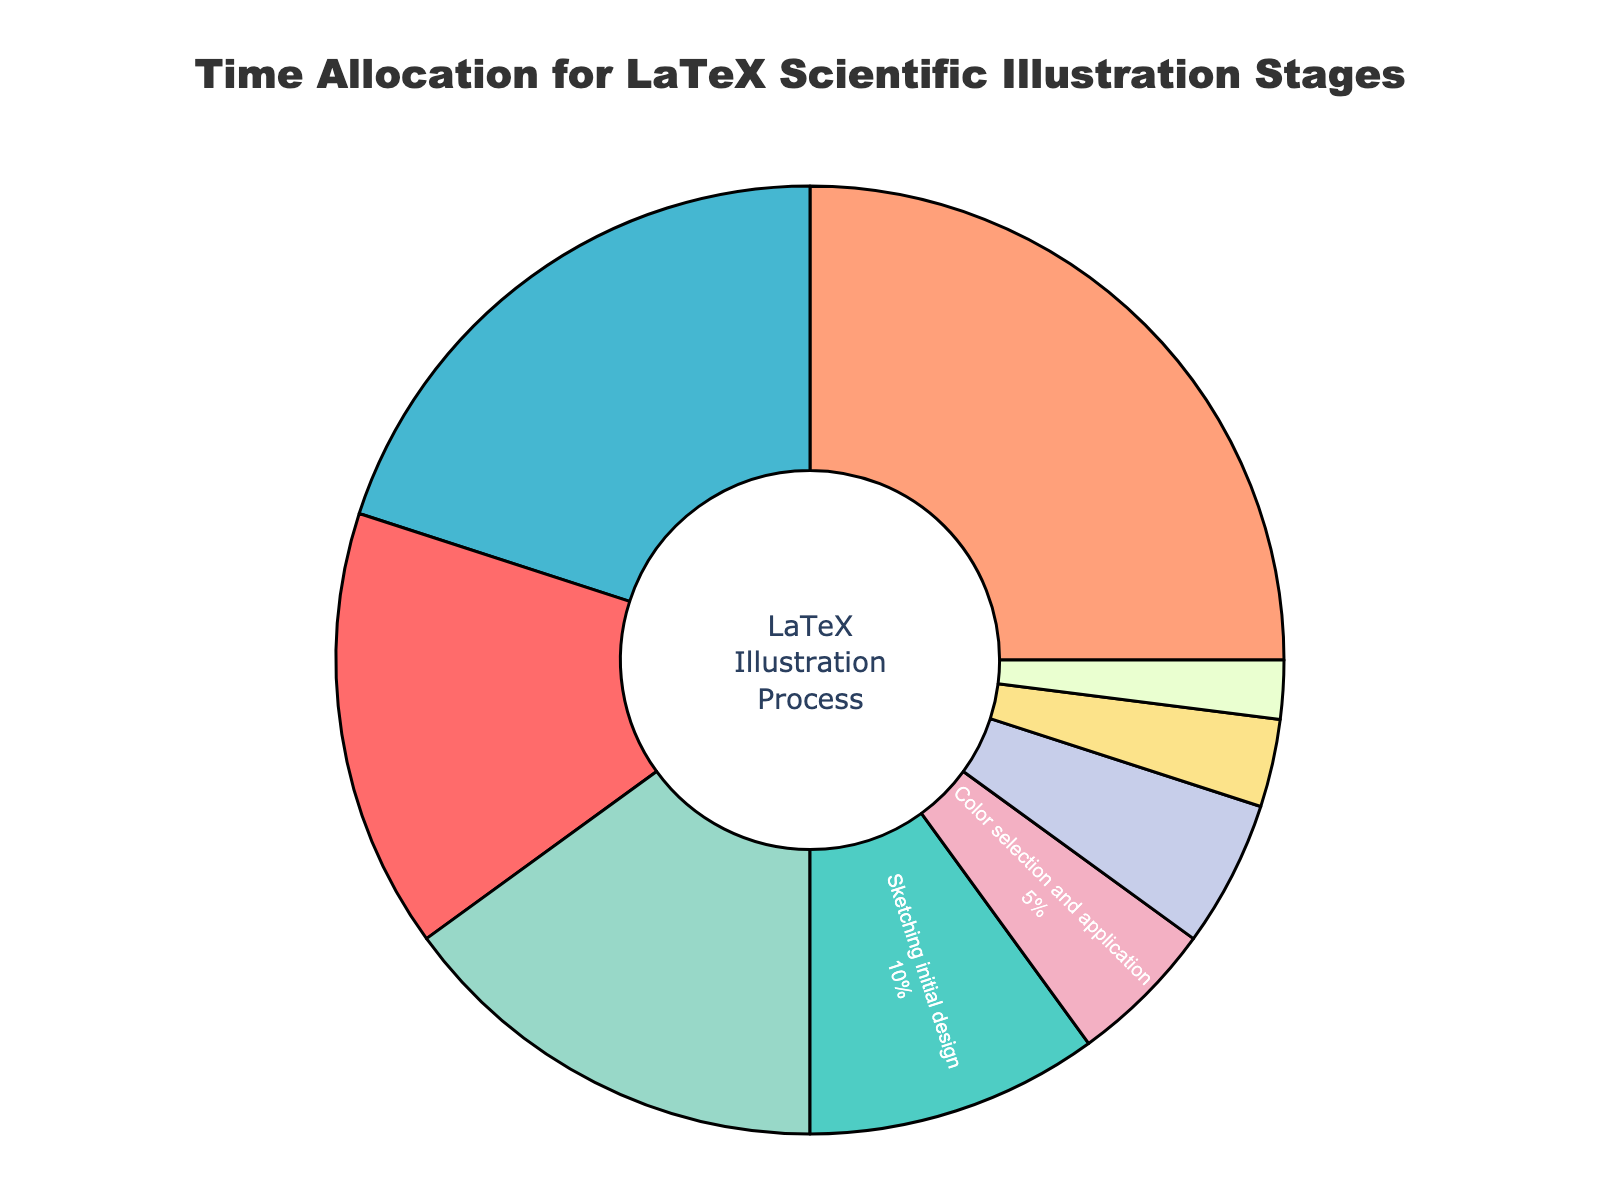Which stage takes the highest percentage of time in the LaTeX scientific illustration process? The LaTeX stage with the highest time allocation is "Writing LaTeX code for diagram structure" with 25%. This is determined by examining the percentage values in the pie chart.
Answer: Writing LaTeX code for diagram structure What is the combined time allocation percentage for "Research and concept development" and "Sketching initial design"? Add the percentages for "Research and concept development" and "Sketching initial design": 15% + 10% = 25%.
Answer: 25% Which stage uses more time, "Creating vector graphics in Inkscape" or "Implementing TikZ for precision elements"? Compare the percentages: "Creating vector graphics in Inkscape" has 20%, while "Implementing TikZ for precision elements" has 15%. 20% is greater than 15%.
Answer: Creating vector graphics in Inkscape What stages take up the smallest percentage of time? Check the smallest percentage values in the pie chart. "Client feedback and revisions" has 2%, which is the smallest, followed by "Rendering and output optimization" with 3%.
Answer: Client feedback and revisions What is the total percentage for stages that involve graphical design? Add the percentages for stages related to graphical design: "Sketching initial design" (10%), "Creating vector graphics in Inkscape" (20%), "Color selection and application" (5%). 10% + 20% + 5% = 35%.
Answer: 35% How does the time allocation for "Proofreading and error correction" compare to "Color selection and application"? Both "Proofreading and error correction" and "Color selection and application" have the same percentage, which is 5%.
Answer: Equal Which color is used for the stage "Research and concept development"? Identify the color in the pie chart corresponding to "Research and concept development", which is red.
Answer: Red Is the combined time for "Rendering and output optimization" and "Client feedback and revisions" greater than "Color selection and application"? Add the percentages for "Rendering and output optimization" and "Client feedback and revisions": 3% + 2% = 5%. "Color selection and application" is also 5%. 5% is equal to 5%.
Answer: No How much more time is spent on "Implementing TikZ for precision elements" compared to "Color selection and application"? Subtract the percentage for "Color selection and application" from "Implementing TikZ for precision elements": 15% - 5% = 10%.
Answer: 10% 